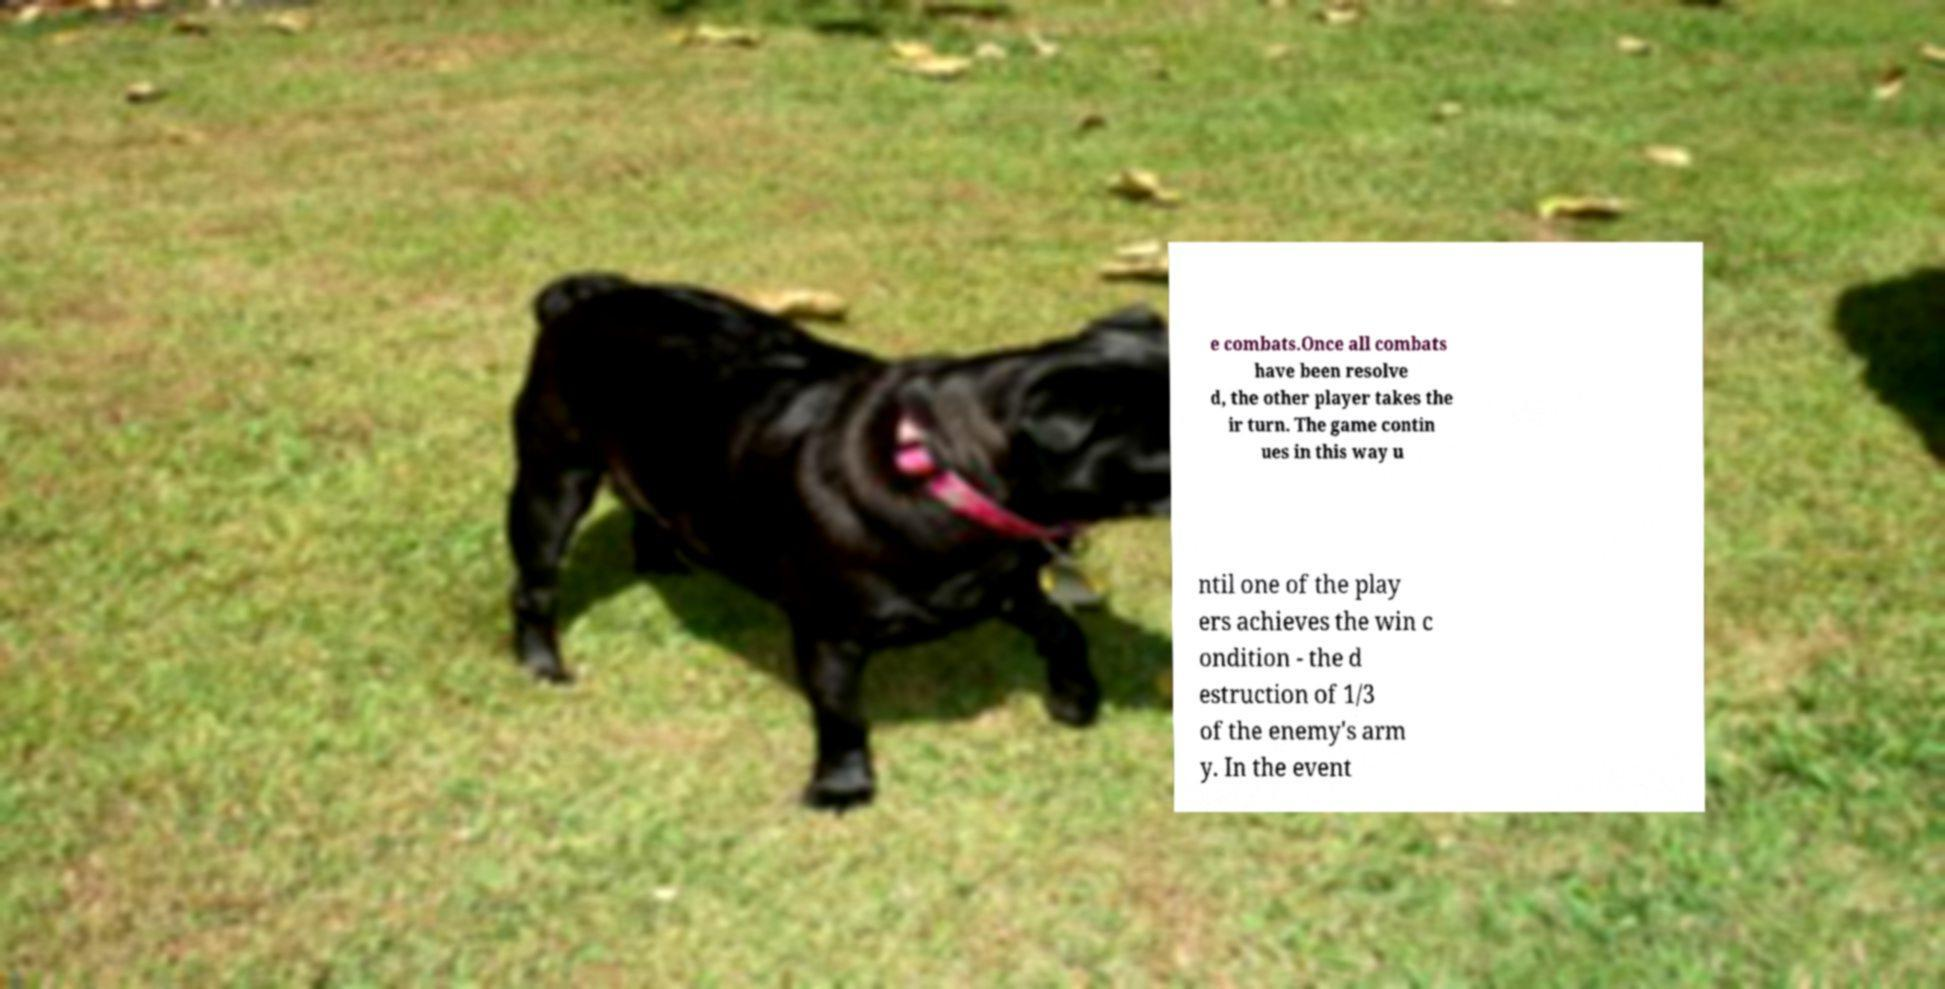I need the written content from this picture converted into text. Can you do that? e combats.Once all combats have been resolve d, the other player takes the ir turn. The game contin ues in this way u ntil one of the play ers achieves the win c ondition - the d estruction of 1/3 of the enemy's arm y. In the event 